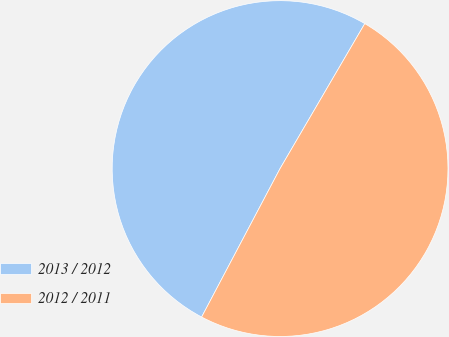Convert chart to OTSL. <chart><loc_0><loc_0><loc_500><loc_500><pie_chart><fcel>2013 / 2012<fcel>2012 / 2011<nl><fcel>50.68%<fcel>49.32%<nl></chart> 